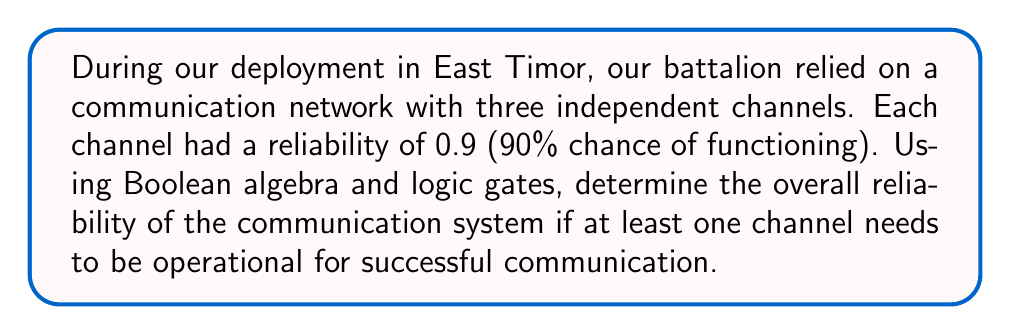Give your solution to this math problem. Let's approach this step-by-step:

1) First, let's define our variables:
   Let $A$, $B$, and $C$ represent the events that channels 1, 2, and 3 are operational, respectively.

2) The probability of each channel working is 0.9:
   $P(A) = P(B) = P(C) = 0.9$

3) The system will fail only if all channels fail. Let's call this event F (failure):
   $F = \overline{A} \cdot \overline{B} \cdot \overline{C}$

4) The probability of a channel failing is:
   $P(\overline{A}) = P(\overline{B}) = P(\overline{C}) = 1 - 0.9 = 0.1$

5) The probability of system failure is:
   $P(F) = P(\overline{A} \cdot \overline{B} \cdot \overline{C}) = P(\overline{A}) \cdot P(\overline{B}) \cdot P(\overline{C}) = 0.1 \cdot 0.1 \cdot 0.1 = 0.001$

6) The reliability of the system (R) is the opposite of failure:
   $R = 1 - P(F) = 1 - 0.001 = 0.999$

7) This can also be represented using logic gates. The system is operational if A OR B OR C is true, which can be represented by an OR gate with three inputs.

[asy]
unitsize(1cm);

draw((0,0)--(6,0)--(6,3)--(0,3)--cycle);
draw((0,1.5)--(1,1.5));
draw((0,2.5)--(1,2.5));
draw((0,0.5)--(1,0.5));
draw((5,1.5)--(6,1.5));

label("A", (0.5,2.5), W);
label("B", (0.5,1.5), W);
label("C", (0.5,0.5), W);
label("Output", (5.5,1.5), E);

path p = (1,0)--(2,0)..(3,1.5)..(4,3)--(5,3)--(5,0)--cycle;
fill(p, gray(0.9));
label("OR", (3,1.5));
[/asy]

8) The Boolean expression for this system is:
   $Output = A + B + C$ (where '+' represents the OR operation)

This analysis shows that our communication system in East Timor was highly reliable, with a 99.9% chance of at least one channel being operational.
Answer: The overall reliability of the communication system is 0.999 or 99.9%. 